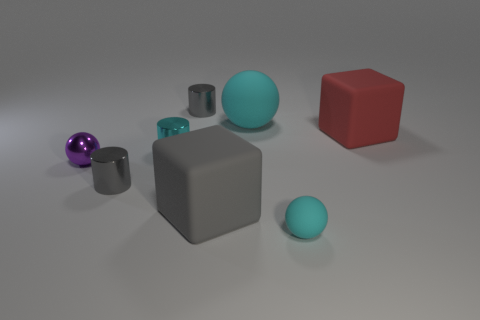Is the shape of the tiny object that is behind the red matte thing the same as the large rubber object that is behind the large red rubber thing?
Offer a terse response. No. There is a gray matte thing; how many things are on the left side of it?
Your response must be concise. 4. Is the material of the big cube in front of the purple object the same as the large sphere?
Make the answer very short. Yes. What is the color of the other rubber thing that is the same shape as the large red matte object?
Provide a short and direct response. Gray. The tiny purple object has what shape?
Make the answer very short. Sphere. What number of objects are big matte things or gray blocks?
Your response must be concise. 3. Do the cube to the right of the tiny cyan matte sphere and the big block in front of the metallic ball have the same color?
Make the answer very short. No. What number of other objects are the same shape as the purple metallic object?
Make the answer very short. 2. Are there any tiny gray shiny objects?
Keep it short and to the point. Yes. What number of things are tiny rubber objects or cyan balls that are in front of the large cyan rubber thing?
Give a very brief answer. 1. 